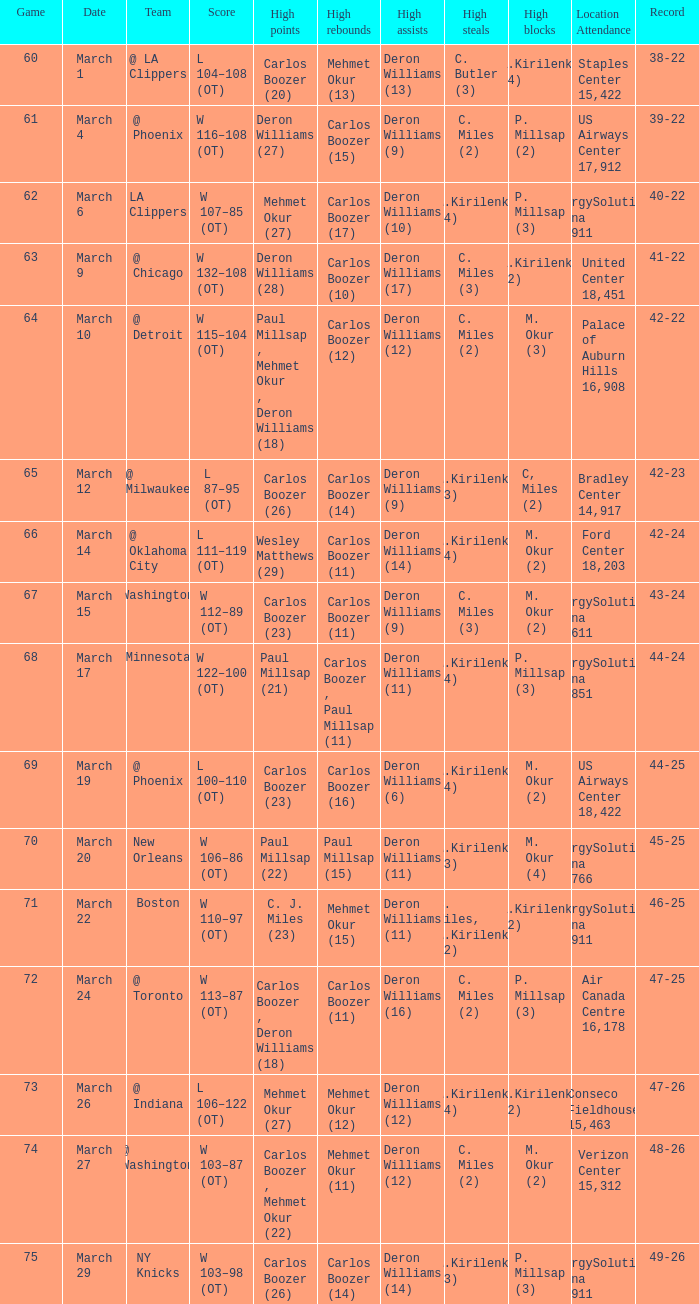Where was the March 24 game played? Air Canada Centre 16,178. Would you mind parsing the complete table? {'header': ['Game', 'Date', 'Team', 'Score', 'High points', 'High rebounds', 'High assists', 'High steals', 'High blocks', 'Location Attendance', 'Record'], 'rows': [['60', 'March 1', '@ LA Clippers', 'L 104–108 (OT)', 'Carlos Boozer (20)', 'Mehmet Okur (13)', 'Deron Williams (13)', 'C. Butler (3)', 'A.Kirilenko (4)', 'Staples Center 15,422', '38-22'], ['61', 'March 4', '@ Phoenix', 'W 116–108 (OT)', 'Deron Williams (27)', 'Carlos Boozer (15)', 'Deron Williams (9)', 'C. Miles (2)', 'P. Millsap (2)', 'US Airways Center 17,912', '39-22'], ['62', 'March 6', 'LA Clippers', 'W 107–85 (OT)', 'Mehmet Okur (27)', 'Carlos Boozer (17)', 'Deron Williams (10)', 'A.Kirilenko (4)', 'P. Millsap (3)', 'EnergySolutions Arena 19,911', '40-22'], ['63', 'March 9', '@ Chicago', 'W 132–108 (OT)', 'Deron Williams (28)', 'Carlos Boozer (10)', 'Deron Williams (17)', 'C. Miles (3)', 'A.Kirilenko (2)', 'United Center 18,451', '41-22'], ['64', 'March 10', '@ Detroit', 'W 115–104 (OT)', 'Paul Millsap , Mehmet Okur , Deron Williams (18)', 'Carlos Boozer (12)', 'Deron Williams (12)', 'C. Miles (2)', 'M. Okur (3)', 'Palace of Auburn Hills 16,908', '42-22'], ['65', 'March 12', '@ Milwaukee', 'L 87–95 (OT)', 'Carlos Boozer (26)', 'Carlos Boozer (14)', 'Deron Williams (9)', 'A.Kirilenko (3)', 'C, Miles (2)', 'Bradley Center 14,917', '42-23'], ['66', 'March 14', '@ Oklahoma City', 'L 111–119 (OT)', 'Wesley Matthews (29)', 'Carlos Boozer (11)', 'Deron Williams (14)', 'A.Kirilenko (4)', 'M. Okur (2)', 'Ford Center 18,203', '42-24'], ['67', 'March 15', 'Washington', 'W 112–89 (OT)', 'Carlos Boozer (23)', 'Carlos Boozer (11)', 'Deron Williams (9)', 'C. Miles (3)', 'M. Okur (2)', 'EnergySolutions Arena 19,611', '43-24'], ['68', 'March 17', 'Minnesota', 'W 122–100 (OT)', 'Paul Millsap (21)', 'Carlos Boozer , Paul Millsap (11)', 'Deron Williams (11)', 'A.Kirilenko (4)', 'P. Millsap (3)', 'EnergySolutions Arena 19,851', '44-24'], ['69', 'March 19', '@ Phoenix', 'L 100–110 (OT)', 'Carlos Boozer (23)', 'Carlos Boozer (16)', 'Deron Williams (6)', 'A.Kirilenko (4)', 'M. Okur (2)', 'US Airways Center 18,422', '44-25'], ['70', 'March 20', 'New Orleans', 'W 106–86 (OT)', 'Paul Millsap (22)', 'Paul Millsap (15)', 'Deron Williams (11)', 'A.Kirilenko (3)', 'M. Okur (4)', 'EnergySolutions Arena 18,766', '45-25'], ['71', 'March 22', 'Boston', 'W 110–97 (OT)', 'C. J. Miles (23)', 'Mehmet Okur (15)', 'Deron Williams (11)', 'C. Miles, A.Kirilenko (2)', 'A.Kirilenko (2)', 'EnergySolutions Arena 19,911', '46-25'], ['72', 'March 24', '@ Toronto', 'W 113–87 (OT)', 'Carlos Boozer , Deron Williams (18)', 'Carlos Boozer (11)', 'Deron Williams (16)', 'C. Miles (2)', 'P. Millsap (3)', 'Air Canada Centre 16,178', '47-25'], ['73', 'March 26', '@ Indiana', 'L 106–122 (OT)', 'Mehmet Okur (27)', 'Mehmet Okur (12)', 'Deron Williams (12)', 'A.Kirilenko (4)', 'A.Kirilenko (2)', 'Conseco Fieldhouse 15,463', '47-26'], ['74', 'March 27', '@ Washington', 'W 103–87 (OT)', 'Carlos Boozer , Mehmet Okur (22)', 'Mehmet Okur (11)', 'Deron Williams (12)', 'C. Miles (2)', 'M. Okur (2)', 'Verizon Center 15,312', '48-26'], ['75', 'March 29', 'NY Knicks', 'W 103–98 (OT)', 'Carlos Boozer (26)', 'Carlos Boozer (14)', 'Deron Williams (14)', 'A.Kirilenko (3)', 'P. Millsap (3)', 'EnergySolutions Arena 19,911', '49-26']]} 